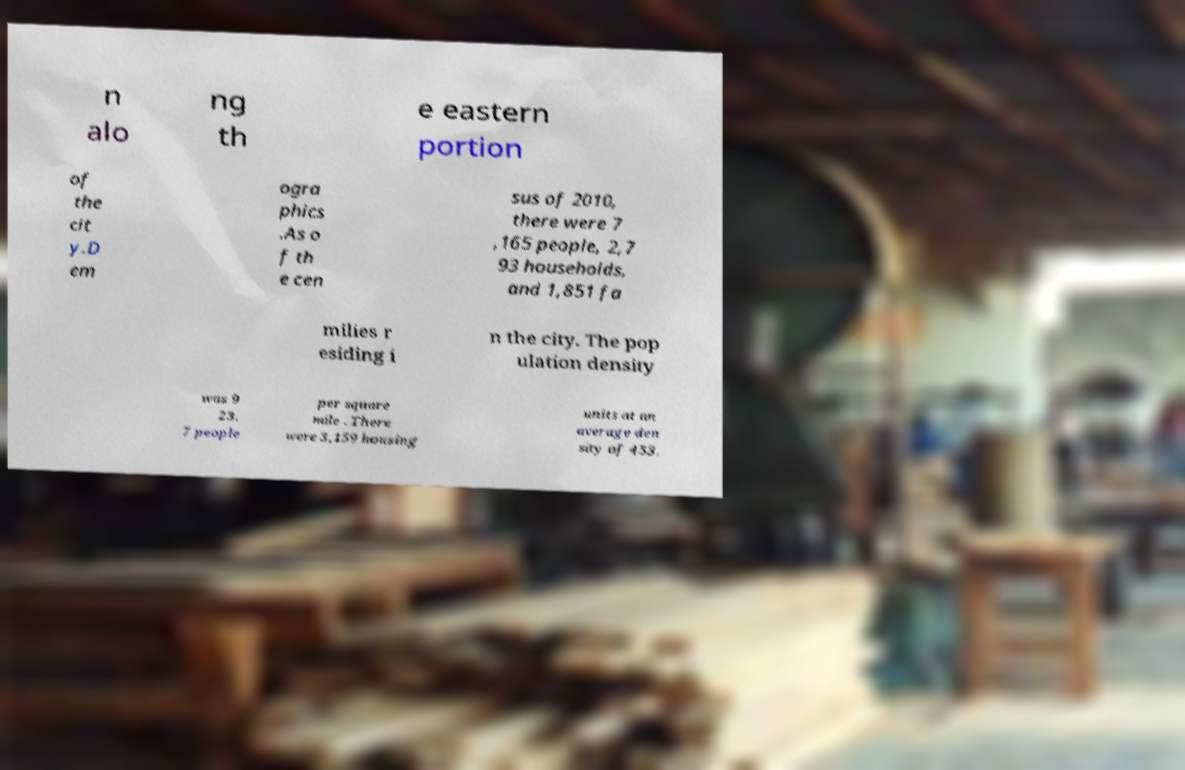Could you assist in decoding the text presented in this image and type it out clearly? n alo ng th e eastern portion of the cit y.D em ogra phics .As o f th e cen sus of 2010, there were 7 ,165 people, 2,7 93 households, and 1,851 fa milies r esiding i n the city. The pop ulation density was 9 23. 7 people per square mile . There were 3,159 housing units at an average den sity of 453. 